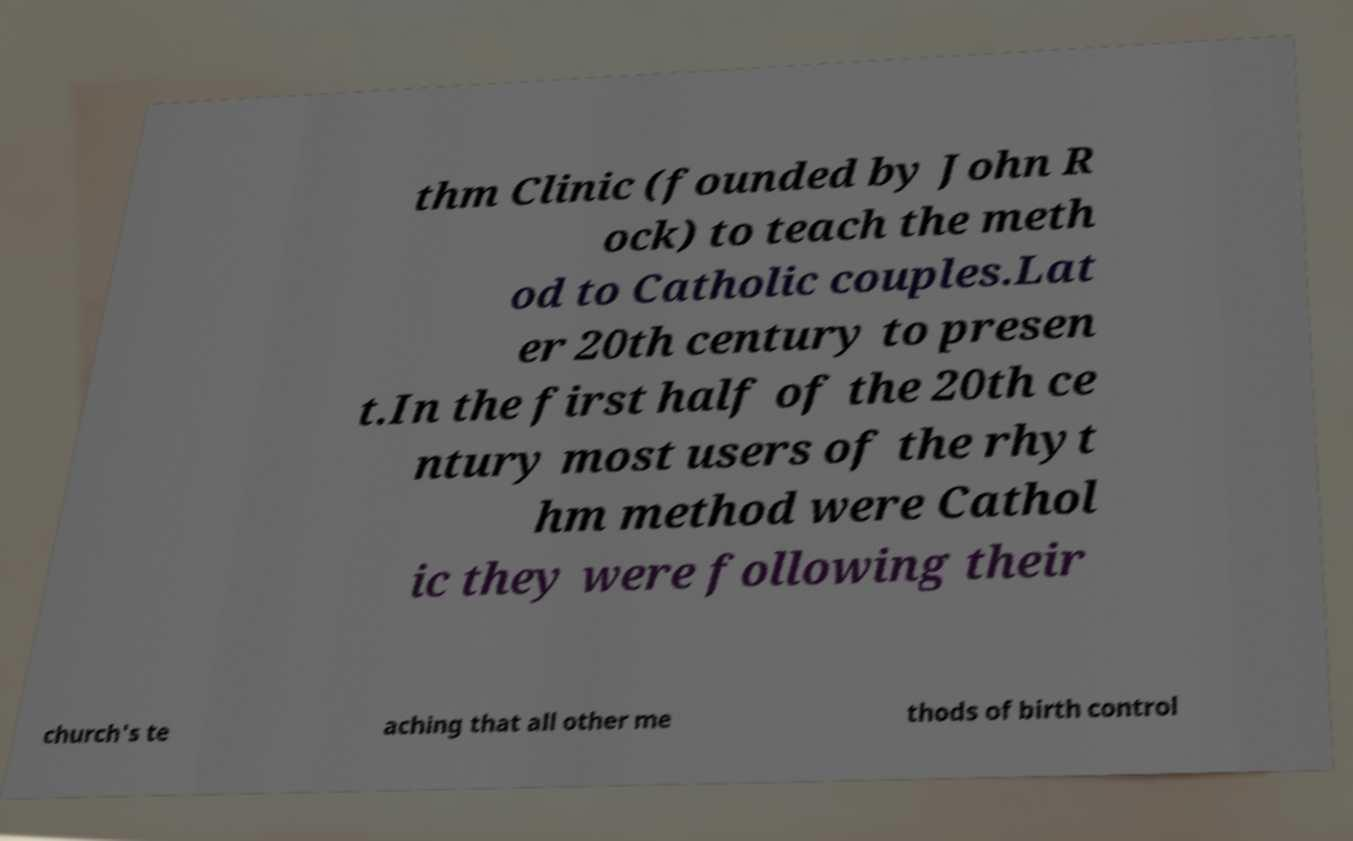Could you extract and type out the text from this image? thm Clinic (founded by John R ock) to teach the meth od to Catholic couples.Lat er 20th century to presen t.In the first half of the 20th ce ntury most users of the rhyt hm method were Cathol ic they were following their church's te aching that all other me thods of birth control 